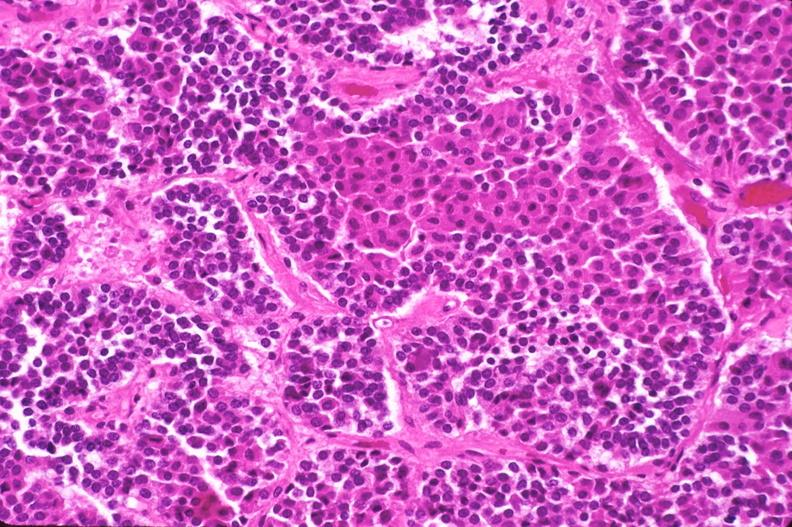what is present?
Answer the question using a single word or phrase. Endocrine 